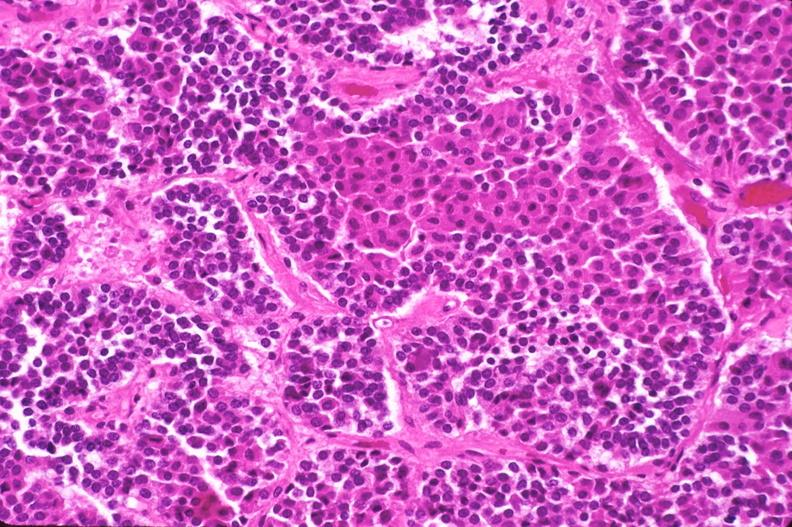what is present?
Answer the question using a single word or phrase. Endocrine 